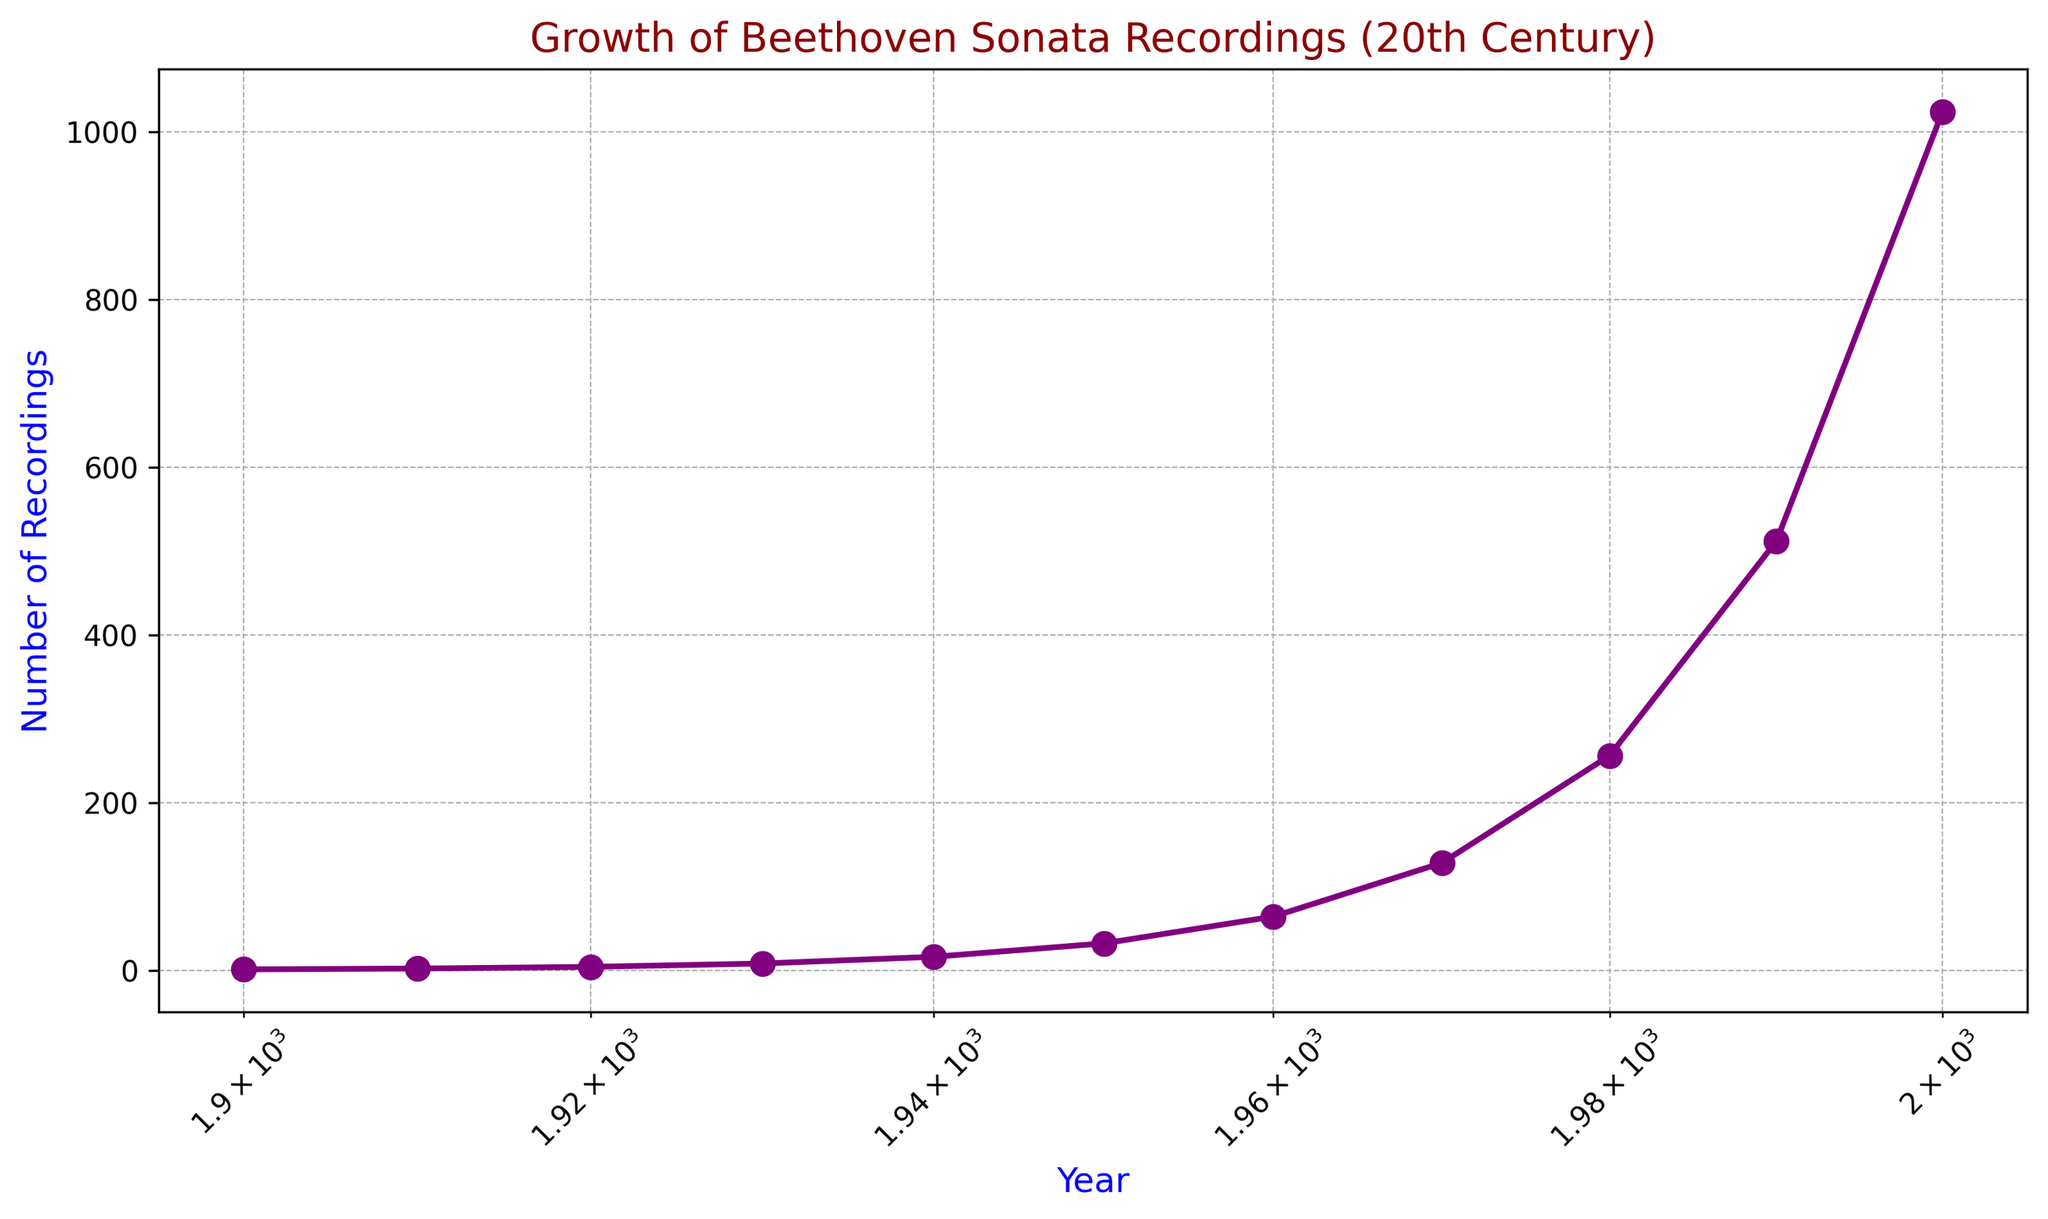What is the trend of Beethoven Sonata recordings over the 20th century? By observing the plot, it is evident that the number of recordings increased exponentially throughout the 20th century, with each decade showing a doubling effect in the number of recordings. The data points exhibit a steep upward trajectory.
Answer: Exponential growth Which decade saw the most significant increase in the number of recordings? To determine the decade with the most significant increase, compare the differences in the number of recordings between consecutive decades. From 1990 to 2000, the increase was the highest, from 512 to 1024 recordings, showing an addition of 512 recordings.
Answer: 1990-2000 How does the number of recordings in 1950 compare to 1930? Looking at the data points on the chart for 1950 and 1930, the number of recordings in 1950 (which is 32) is four times greater than the number in 1930 (which is 8).
Answer: Four times greater At what year does the number of recordings reach 128? Reviewing the plot, the data point for 1970 shows that the number of recordings reached 128 in that year.
Answer: 1970 What color is the line plot representing the growth of Beethoven Sonata recordings? By visually examining the line in the plot, it is clear that the line plot representing the growth of recordings is purple.
Answer: Purple What is the number of recordings in the first and last decade of the 20th century? From the plot, the number of recordings in 1900 is 1, and in 2000 it is 1024. These are the data points on the farthest left and right of the plot respectively.
Answer: 1 and 1024 Calculate the average number of recordings in the first three decades (1900-1930). To find the average, sum the recordings from 1900 (1), 1910 (2), and 1920 (4), which is 1 + 2 + 4 = 7. Next, divide by 3 (the number of decades): 7 / 3 ≈ 2.33.
Answer: ≈ 2.33 What is the growth rate between 1920 and 1960? Calculate the growth rate by dividing the number of recordings in 1960 (64) by the number in 1920 (4). Thus, 64 / 4 = 16. So, the number of recordings grew 16 times from 1920 to 1960.
Answer: 16 times When does the number of recordings surpass 500? By observing the plot, the number of recordings surpasses 500 between 1980 (256 recordings) and 1990 (512 recordings). Thus, 1990 is the first year the recordings are above 500.
Answer: 1990 